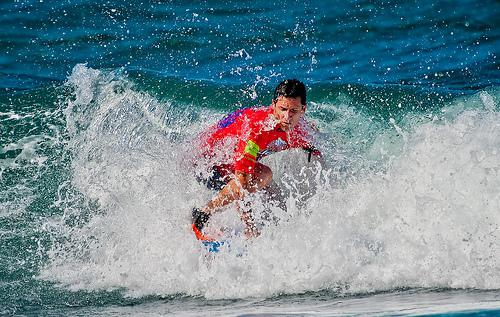Question: where is he?
Choices:
A. On the boat.
B. On the beach.
C. On a surfboard.
D. In the park.
Answer with the letter. Answer: C Question: what is he doing?
Choices:
A. Skiing.
B. Diving.
C. Boxing.
D. Surfing.
Answer with the letter. Answer: D Question: why is he surfing?
Choices:
A. Exercise.
B. Fitness.
C. Fun.
D. Enjoyment.
Answer with the letter. Answer: C Question: what is he on?
Choices:
A. Surfboard.
B. Skis.
C. Diving board.
D. Ladder.
Answer with the letter. Answer: A Question: what are formed?
Choices:
A. Crystals.
B. Waves.
C. Bubbles.
D. Spots.
Answer with the letter. Answer: B 